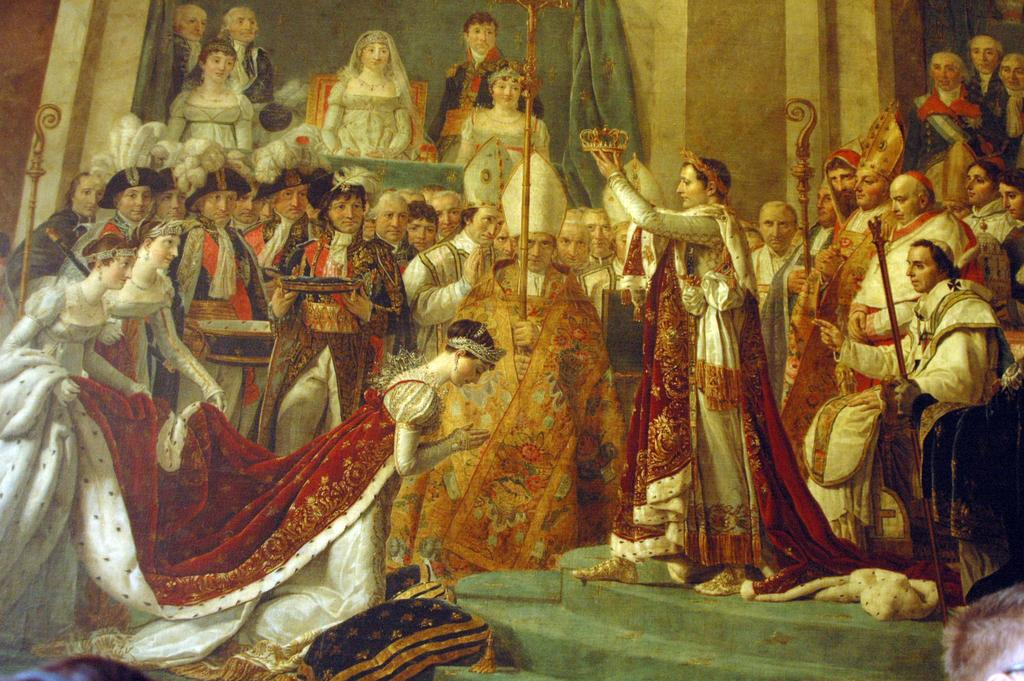How many people are in the image? There are many people depicted in the image. What can be observed about the attire of the people in the image? The people are wearing different costumes. How deep is the hole in the image? There is no hole present in the image. What is the name of the son of the person wearing the red costume? The image does not provide any information about the names of the people or their relationships, so it cannot be determined. 